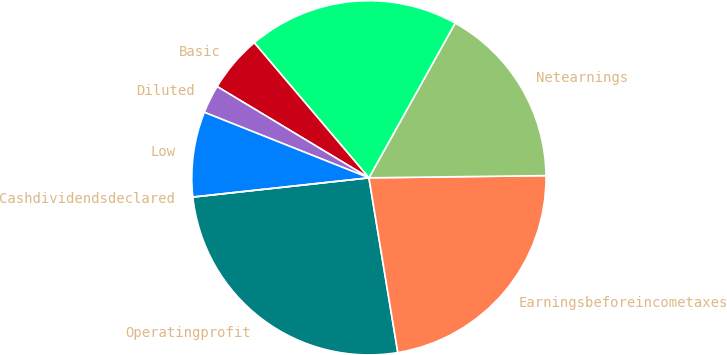Convert chart. <chart><loc_0><loc_0><loc_500><loc_500><pie_chart><fcel>Operatingprofit<fcel>Earningsbeforeincometaxes<fcel>Netearnings<fcel>Unnamed: 3<fcel>Basic<fcel>Diluted<fcel>Low<fcel>Cashdividendsdeclared<nl><fcel>25.88%<fcel>22.59%<fcel>16.71%<fcel>19.3%<fcel>5.18%<fcel>2.59%<fcel>7.76%<fcel>0.0%<nl></chart> 